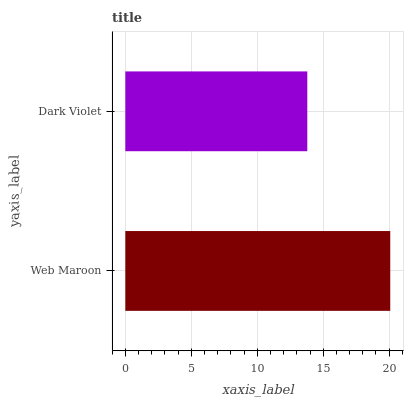Is Dark Violet the minimum?
Answer yes or no. Yes. Is Web Maroon the maximum?
Answer yes or no. Yes. Is Dark Violet the maximum?
Answer yes or no. No. Is Web Maroon greater than Dark Violet?
Answer yes or no. Yes. Is Dark Violet less than Web Maroon?
Answer yes or no. Yes. Is Dark Violet greater than Web Maroon?
Answer yes or no. No. Is Web Maroon less than Dark Violet?
Answer yes or no. No. Is Web Maroon the high median?
Answer yes or no. Yes. Is Dark Violet the low median?
Answer yes or no. Yes. Is Dark Violet the high median?
Answer yes or no. No. Is Web Maroon the low median?
Answer yes or no. No. 